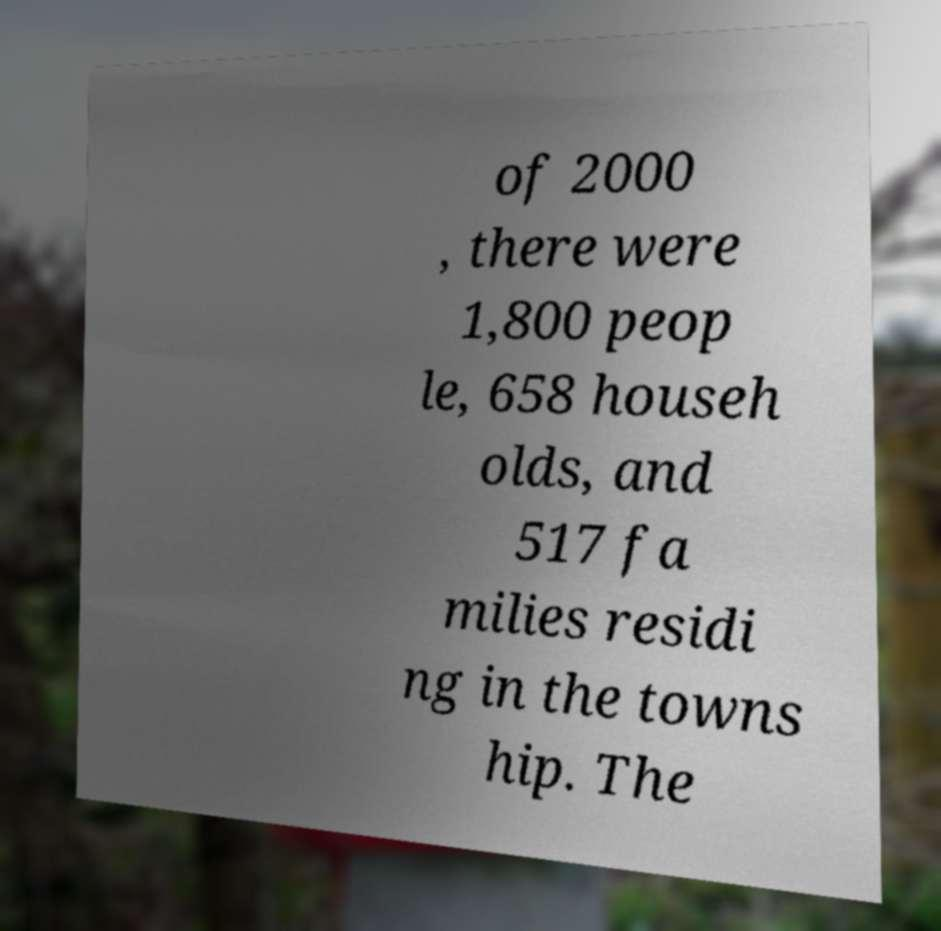For documentation purposes, I need the text within this image transcribed. Could you provide that? of 2000 , there were 1,800 peop le, 658 househ olds, and 517 fa milies residi ng in the towns hip. The 